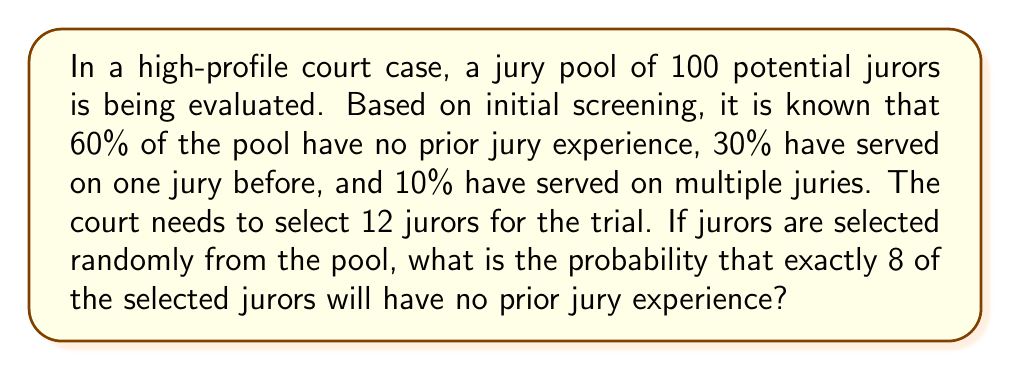Solve this math problem. To solve this problem, we'll use the binomial probability distribution, as we're dealing with a fixed number of independent trials (selecting 12 jurors) with two possible outcomes for each trial (having no prior experience or having some experience).

Let's define our variables:
$n = 12$ (number of jurors to be selected)
$k = 8$ (number of jurors we want with no prior experience)
$p = 0.60$ (probability of selecting a juror with no prior experience)

The probability of selecting exactly 8 jurors with no prior experience out of 12 can be calculated using the binomial probability formula:

$$P(X = k) = \binom{n}{k} p^k (1-p)^{n-k}$$

Where:
$\binom{n}{k}$ is the binomial coefficient, calculated as $\frac{n!}{k!(n-k)!}$

Step 1: Calculate the binomial coefficient
$$\binom{12}{8} = \frac{12!}{8!(12-8)!} = \frac{12!}{8!4!} = 495$$

Step 2: Calculate $p^k$
$$0.60^8 \approx 0.01678$$

Step 3: Calculate $(1-p)^{n-k}$
$$(1-0.60)^{12-8} = 0.40^4 \approx 0.0256$$

Step 4: Multiply all the components
$$495 \times 0.01678 \times 0.0256 \approx 0.2122$$

Therefore, the probability of selecting exactly 8 jurors with no prior experience out of 12 is approximately 0.2122 or 21.22%.
Answer: The probability is approximately 0.2122 or 21.22%. 